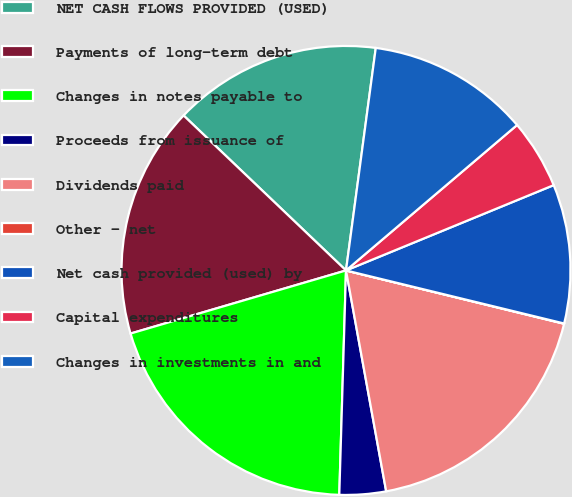<chart> <loc_0><loc_0><loc_500><loc_500><pie_chart><fcel>NET CASH FLOWS PROVIDED (USED)<fcel>Payments of long-term debt<fcel>Changes in notes payable to<fcel>Proceeds from issuance of<fcel>Dividends paid<fcel>Other - net<fcel>Net cash provided (used) by<fcel>Capital expenditures<fcel>Changes in investments in and<nl><fcel>14.99%<fcel>16.66%<fcel>19.99%<fcel>3.34%<fcel>18.32%<fcel>0.02%<fcel>10.0%<fcel>5.01%<fcel>11.67%<nl></chart> 